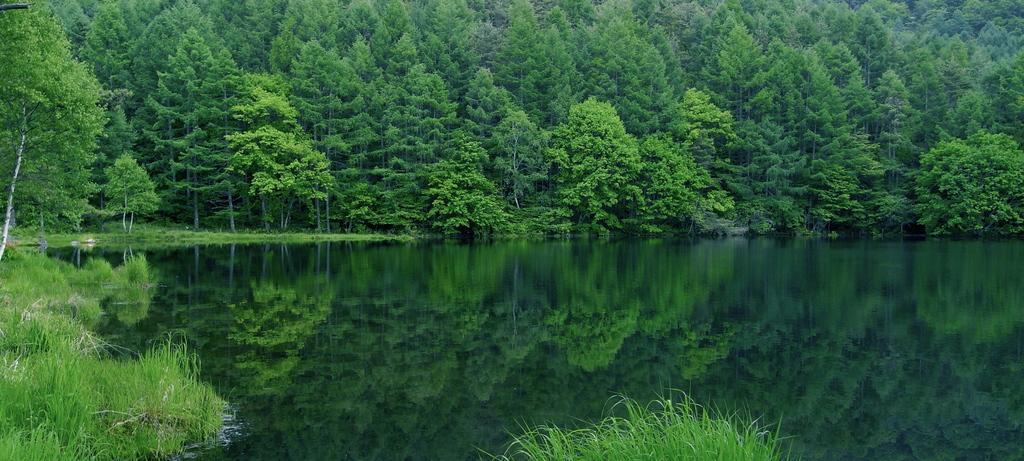Please provide a concise description of this image. In this image, we can see water and there are some green color plants and trees. 